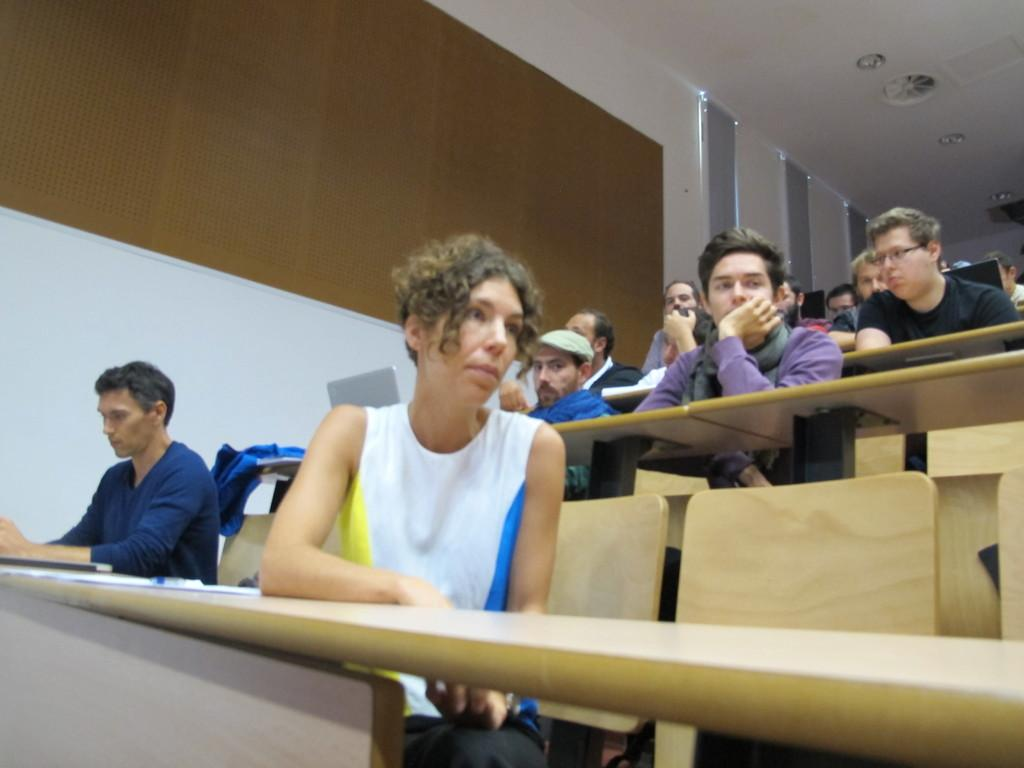How many people are in the image? There is a group of people in the image. What are the people doing in the image? The people are seated on chairs. What furniture is present in the image besides the chairs? There are tables in the image. What electronic device can be seen in the image? A laptop is visible in the image. Can you tell me how many flowers are on the table in the image? There are no flowers present on the table in the image. What type of apparatus is being used by the people in the image? The people in the image are not using any apparatus; they are simply seated on chairs. 